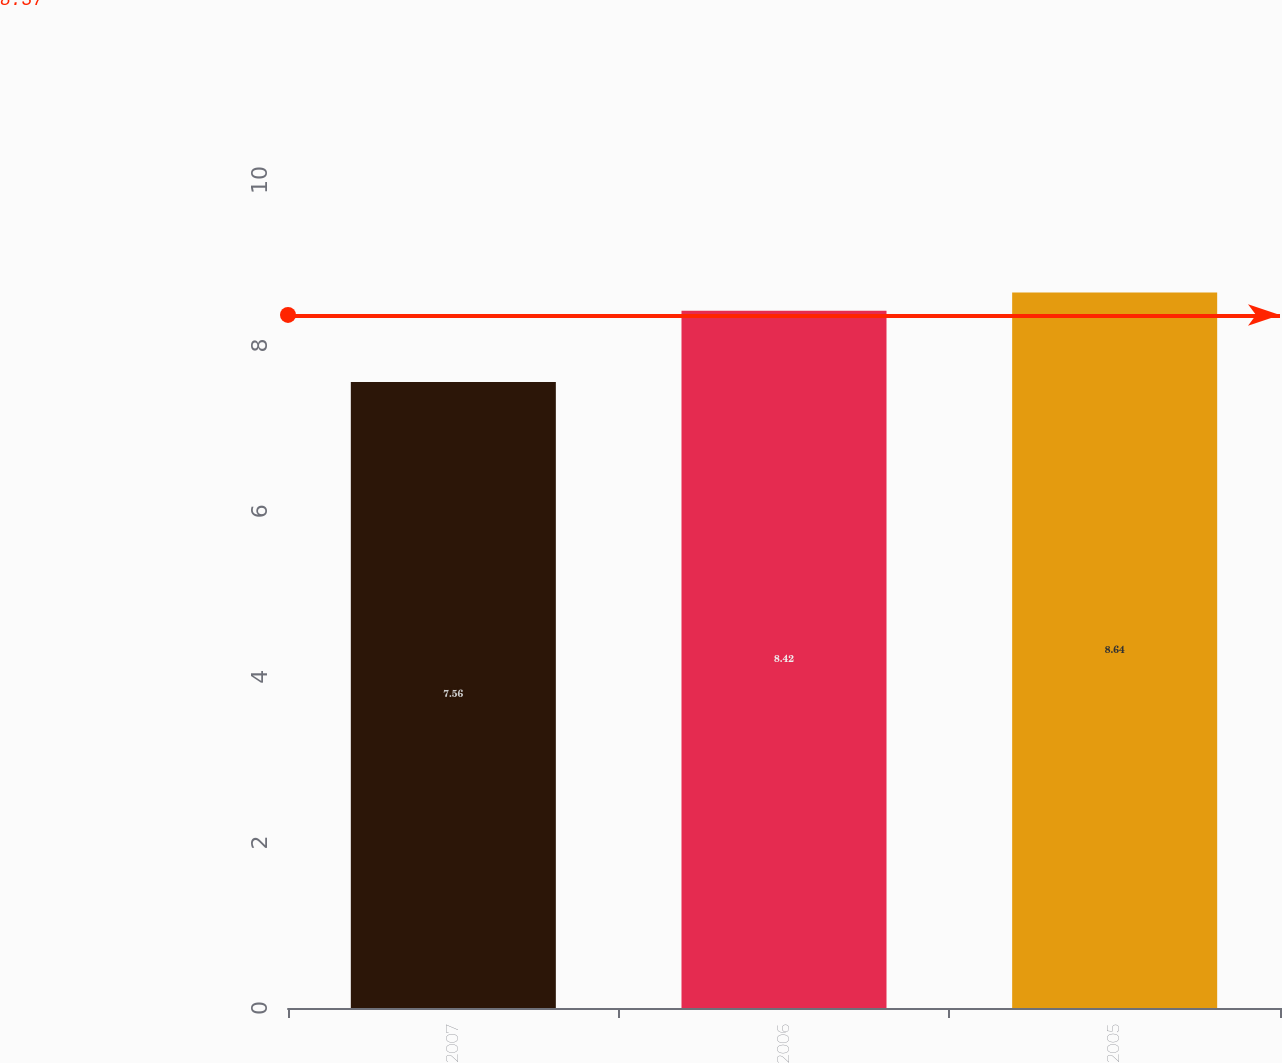Convert chart. <chart><loc_0><loc_0><loc_500><loc_500><bar_chart><fcel>2007<fcel>2006<fcel>2005<nl><fcel>7.56<fcel>8.42<fcel>8.64<nl></chart> 